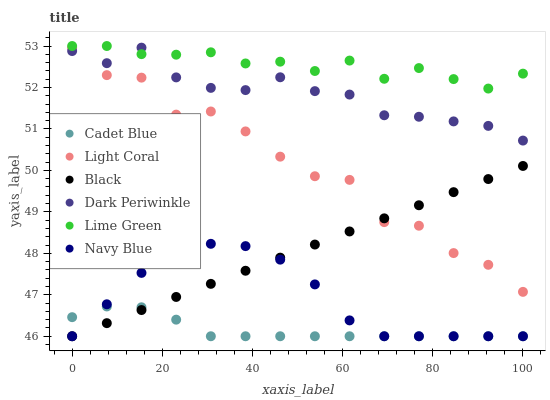Does Cadet Blue have the minimum area under the curve?
Answer yes or no. Yes. Does Lime Green have the maximum area under the curve?
Answer yes or no. Yes. Does Navy Blue have the minimum area under the curve?
Answer yes or no. No. Does Navy Blue have the maximum area under the curve?
Answer yes or no. No. Is Black the smoothest?
Answer yes or no. Yes. Is Light Coral the roughest?
Answer yes or no. Yes. Is Navy Blue the smoothest?
Answer yes or no. No. Is Navy Blue the roughest?
Answer yes or no. No. Does Cadet Blue have the lowest value?
Answer yes or no. Yes. Does Light Coral have the lowest value?
Answer yes or no. No. Does Lime Green have the highest value?
Answer yes or no. Yes. Does Navy Blue have the highest value?
Answer yes or no. No. Is Cadet Blue less than Dark Periwinkle?
Answer yes or no. Yes. Is Light Coral greater than Cadet Blue?
Answer yes or no. Yes. Does Light Coral intersect Black?
Answer yes or no. Yes. Is Light Coral less than Black?
Answer yes or no. No. Is Light Coral greater than Black?
Answer yes or no. No. Does Cadet Blue intersect Dark Periwinkle?
Answer yes or no. No. 